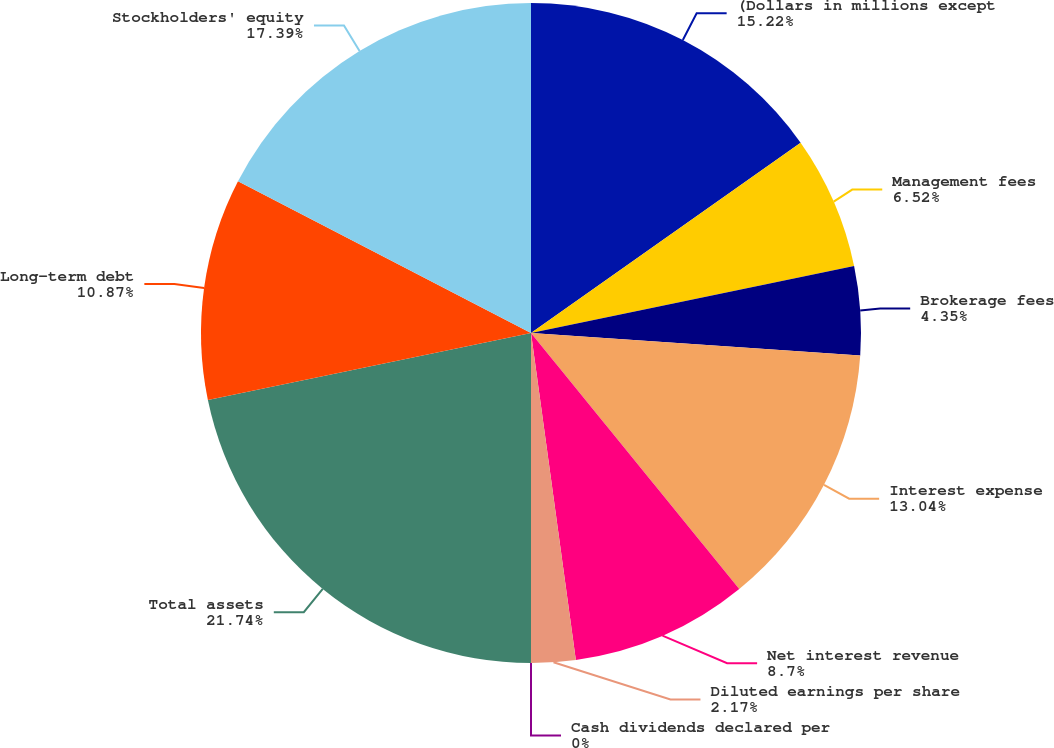<chart> <loc_0><loc_0><loc_500><loc_500><pie_chart><fcel>(Dollars in millions except<fcel>Management fees<fcel>Brokerage fees<fcel>Interest expense<fcel>Net interest revenue<fcel>Diluted earnings per share<fcel>Cash dividends declared per<fcel>Total assets<fcel>Long-term debt<fcel>Stockholders' equity<nl><fcel>15.22%<fcel>6.52%<fcel>4.35%<fcel>13.04%<fcel>8.7%<fcel>2.17%<fcel>0.0%<fcel>21.74%<fcel>10.87%<fcel>17.39%<nl></chart> 